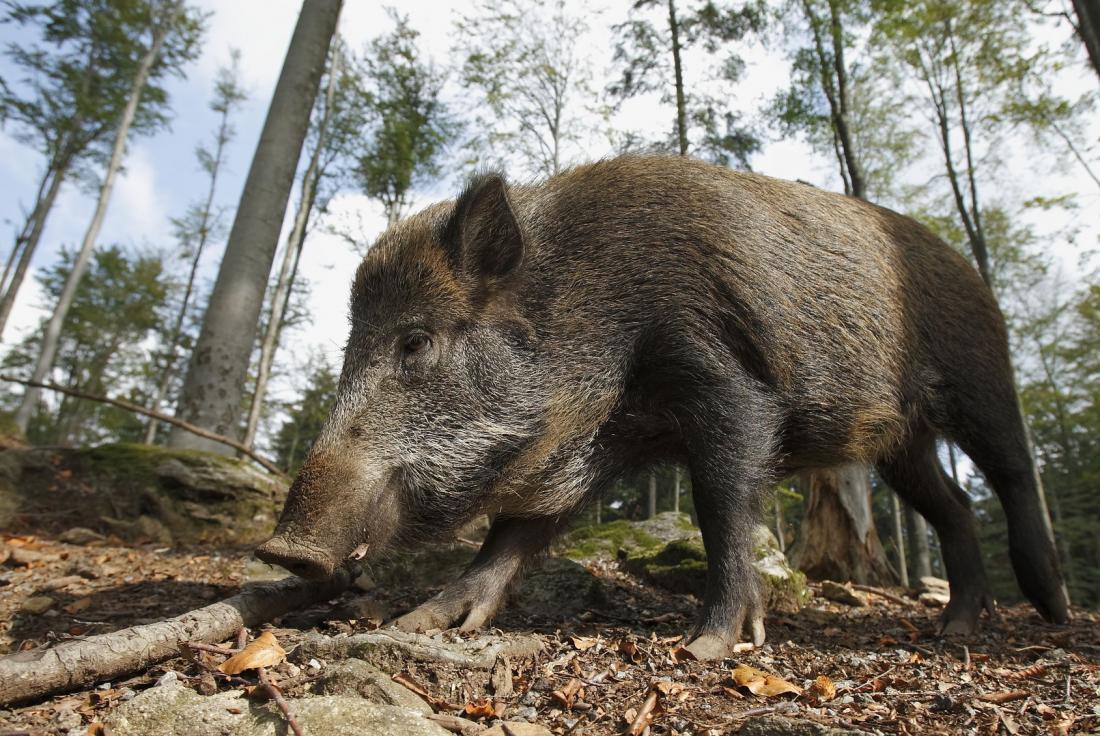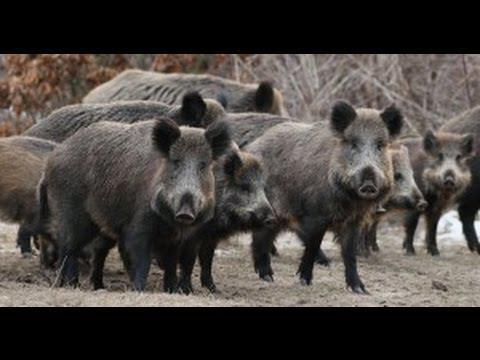The first image is the image on the left, the second image is the image on the right. Examine the images to the left and right. Is the description "The left photo contains two or fewer boars." accurate? Answer yes or no. Yes. The first image is the image on the left, the second image is the image on the right. For the images displayed, is the sentence "The left image contains no more than two wild boars." factually correct? Answer yes or no. Yes. 